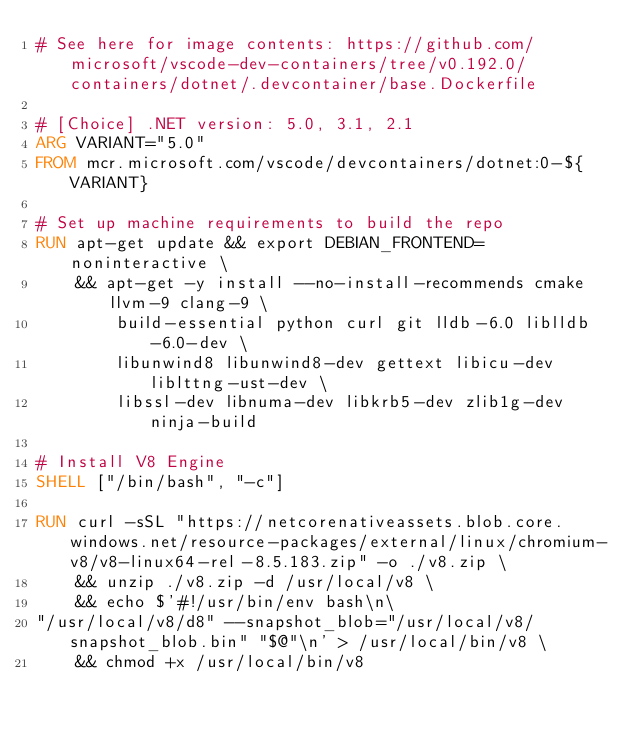Convert code to text. <code><loc_0><loc_0><loc_500><loc_500><_Dockerfile_># See here for image contents: https://github.com/microsoft/vscode-dev-containers/tree/v0.192.0/containers/dotnet/.devcontainer/base.Dockerfile

# [Choice] .NET version: 5.0, 3.1, 2.1
ARG VARIANT="5.0"
FROM mcr.microsoft.com/vscode/devcontainers/dotnet:0-${VARIANT}

# Set up machine requirements to build the repo
RUN apt-get update && export DEBIAN_FRONTEND=noninteractive \
    && apt-get -y install --no-install-recommends cmake llvm-9 clang-9 \
        build-essential python curl git lldb-6.0 liblldb-6.0-dev \
        libunwind8 libunwind8-dev gettext libicu-dev liblttng-ust-dev \
        libssl-dev libnuma-dev libkrb5-dev zlib1g-dev ninja-build

# Install V8 Engine
SHELL ["/bin/bash", "-c"]

RUN curl -sSL "https://netcorenativeassets.blob.core.windows.net/resource-packages/external/linux/chromium-v8/v8-linux64-rel-8.5.183.zip" -o ./v8.zip \
    && unzip ./v8.zip -d /usr/local/v8 \
    && echo $'#!/usr/bin/env bash\n\
"/usr/local/v8/d8" --snapshot_blob="/usr/local/v8/snapshot_blob.bin" "$@"\n' > /usr/local/bin/v8 \
    && chmod +x /usr/local/bin/v8</code> 